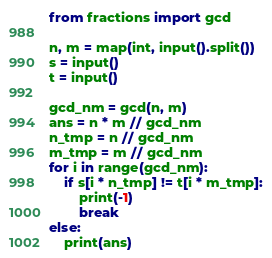Convert code to text. <code><loc_0><loc_0><loc_500><loc_500><_Python_>from fractions import gcd

n, m = map(int, input().split())
s = input()
t = input()

gcd_nm = gcd(n, m)
ans = n * m // gcd_nm
n_tmp = n // gcd_nm
m_tmp = m // gcd_nm
for i in range(gcd_nm):
    if s[i * n_tmp] != t[i * m_tmp]:
        print(-1)
        break
else:
    print(ans)</code> 